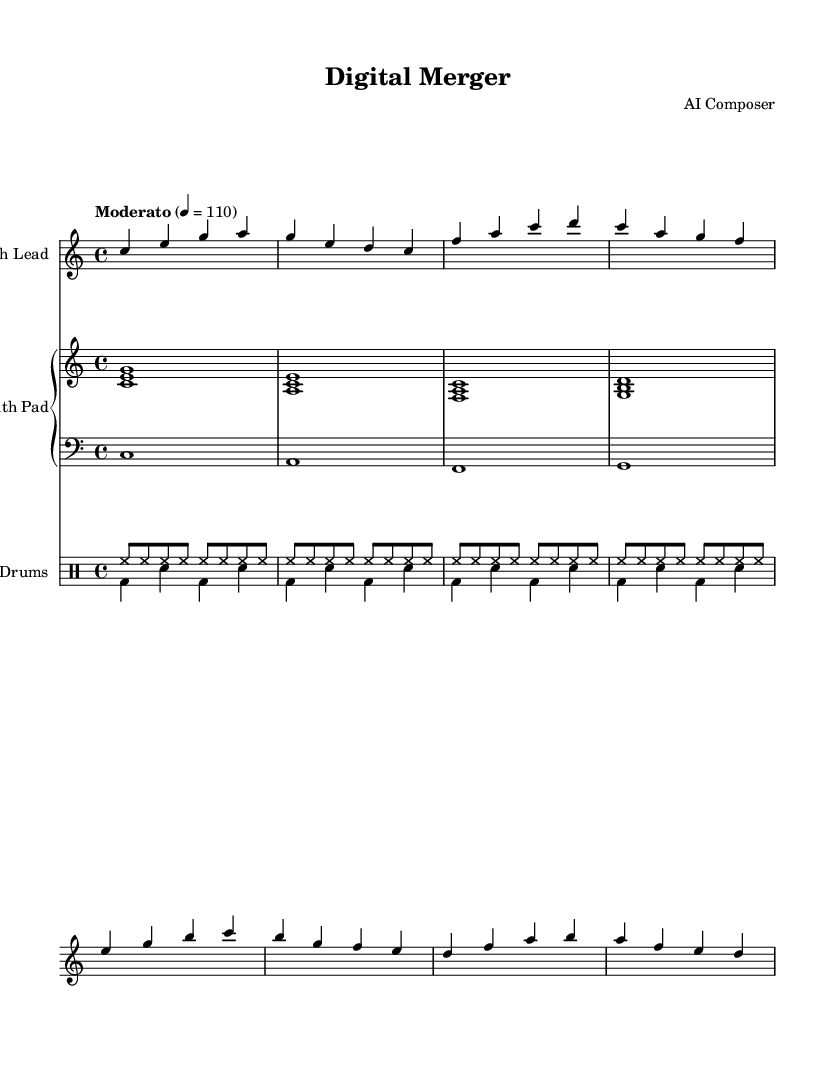What is the key signature of this music? The key signature indicates C major, which has no flats or sharps. This can be determined by analyzing the beginning of the staff where the key signature is typically displayed.
Answer: C major What is the time signature of this composition? The time signature shown at the beginning of the sheet music is 4/4, indicating four beats in a measure and a quarter note receives one beat. This is clearly represented in the upper portion of the first staff.
Answer: 4/4 What is the tempo marking for this piece? The tempo marking states "Moderato" with a metronome marking of 110, suggesting a moderate speed of performance. This information is typically noted above the staff in the tempo indication section.
Answer: Moderato How many measures are there in the synthesizer part? By counting the distinct groups of notes and bar lines in the synthesizer staff, we see there are four measures, each separated by a bar line.
Answer: 4 What is the highest pitch used in the synthesizer melody? The highest note in the synthesizer melody is a "b", which can be identified by looking at the notes being played and locating the highest note’s position on the staff.
Answer: b How many different instrumental parts are shown in this score? The score contains four distinct instrumental parts: Synth Lead, Synth Pad (with upper and lower staves), and Drums. This is evident by reviewing the labeled staves in the score.
Answer: 4 What type of drum pattern is primarily used in this piece? The primary drum pattern used is a combination of closed hi-hat and bass drum with snare, creating a typical electronic dance music rhythm, recognizable in the drum notation.
Answer: Electronic dance music 